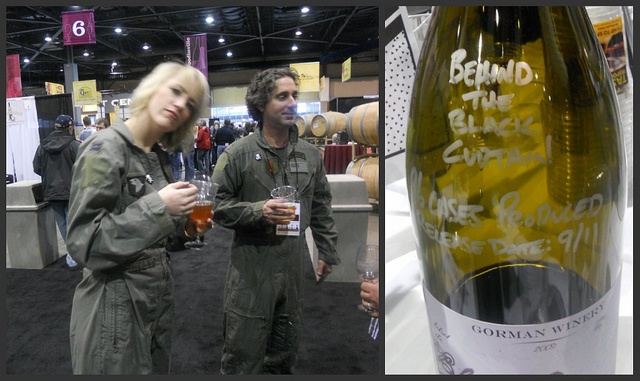Describe the objects in this image and their specific colors. I can see bottle in black, olive, darkgray, and gray tones, people in black, gray, darkgray, and lightgray tones, people in black, gray, and darkgray tones, people in black and gray tones, and wine glass in black, gray, maroon, and darkgray tones in this image. 